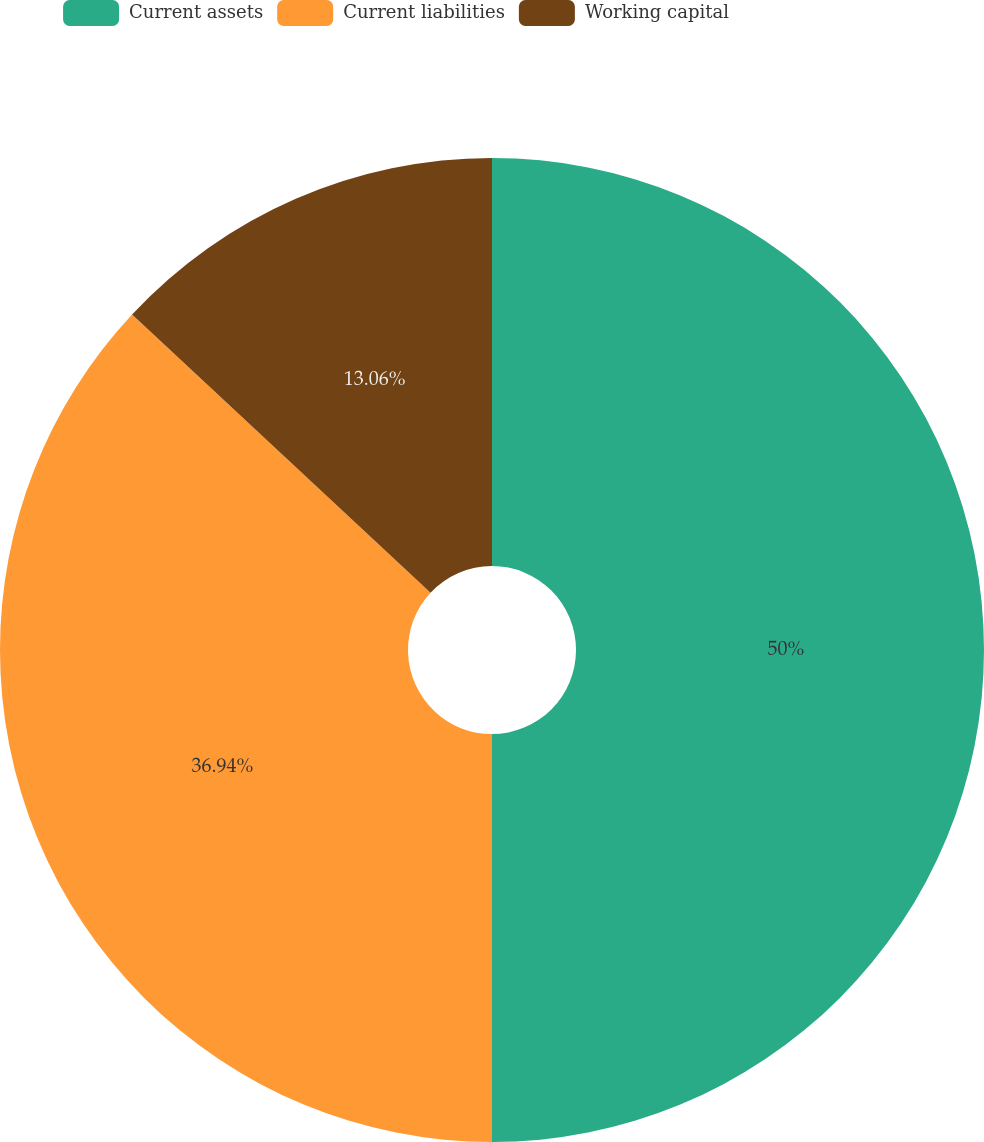Convert chart. <chart><loc_0><loc_0><loc_500><loc_500><pie_chart><fcel>Current assets<fcel>Current liabilities<fcel>Working capital<nl><fcel>50.0%<fcel>36.94%<fcel>13.06%<nl></chart> 